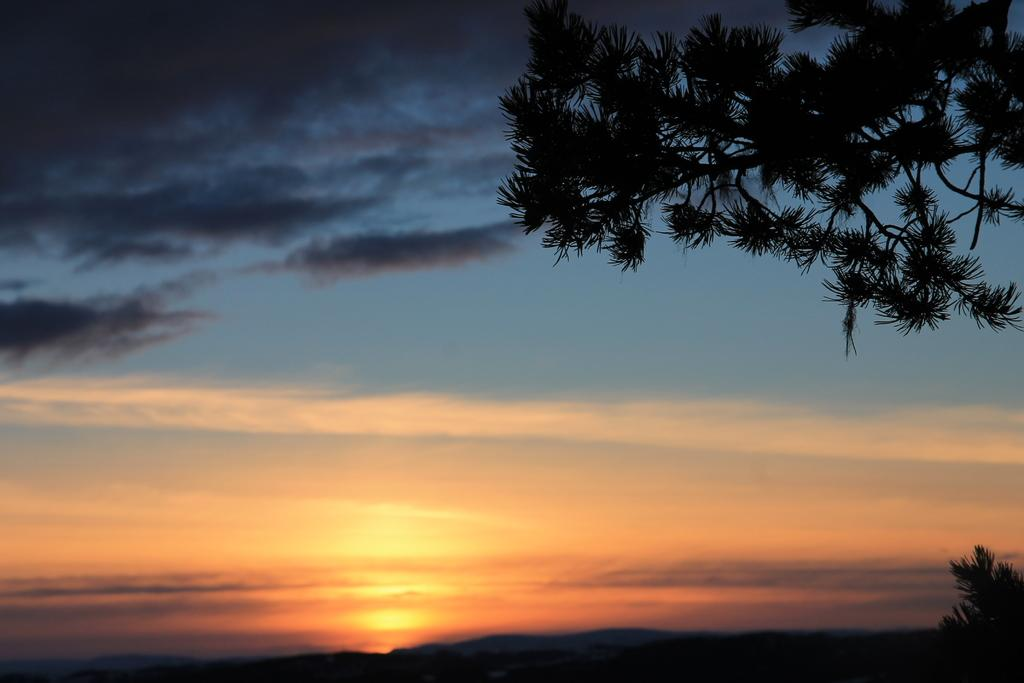What type of natural elements can be seen in the image? There are trees and hills in the image. What is visible in the background of the image? The sky is visible in the image. What can be observed in the sky? Clouds are present in the sky. What hobbies does the secretary have, as seen in the image? There is no secretary present in the image, so it's not possible to determine their hobbies. Can you tell me what is written in the notebook in the image? There is no notebook present in the image. 